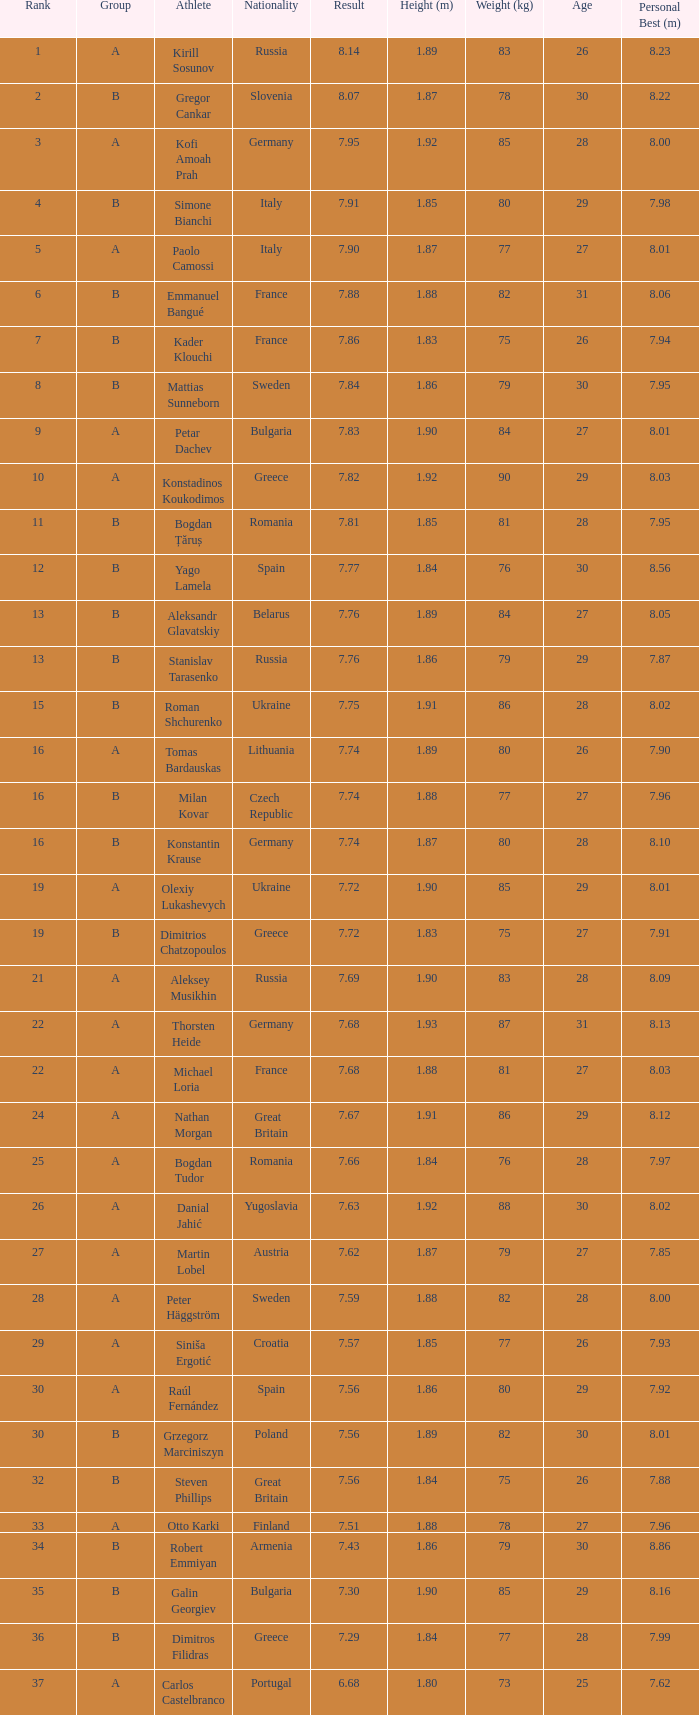Which athlete's rank is more than 15 when the result is less than 7.68, the group is b, and the nationality listed is Great Britain? Steven Phillips. 